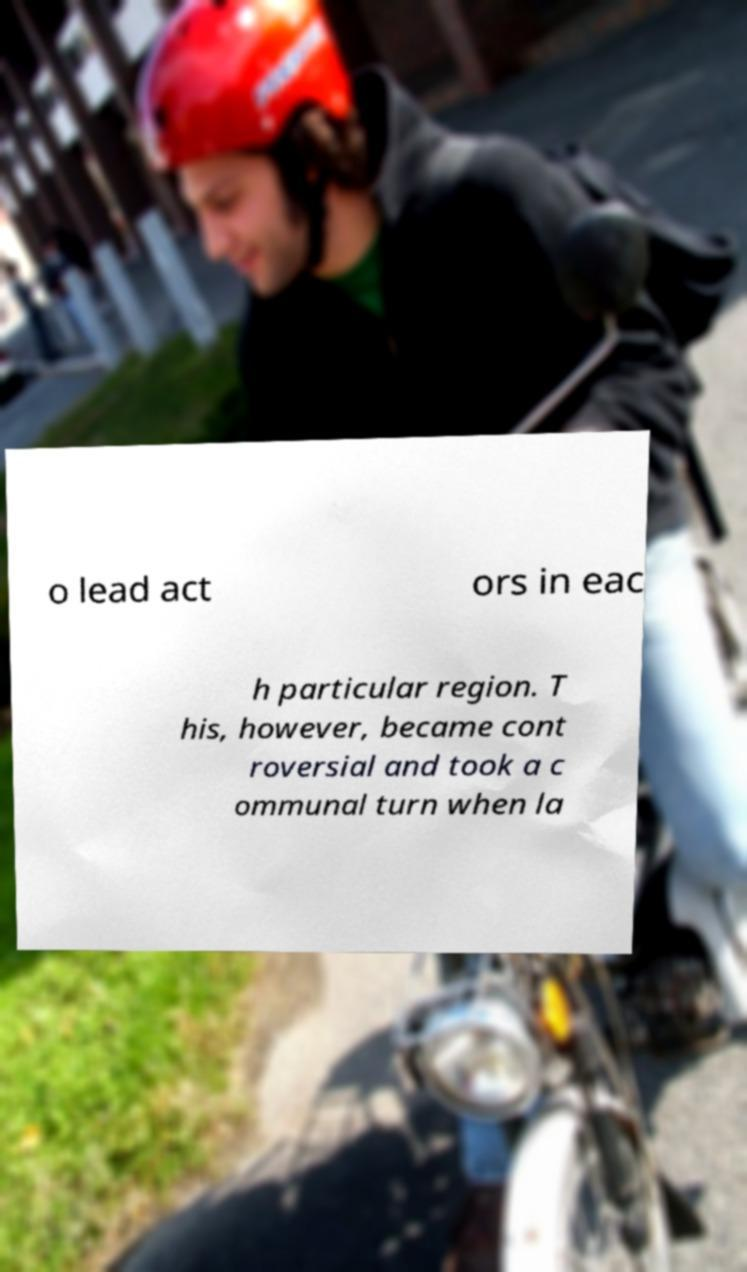Can you read and provide the text displayed in the image?This photo seems to have some interesting text. Can you extract and type it out for me? o lead act ors in eac h particular region. T his, however, became cont roversial and took a c ommunal turn when la 